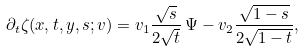Convert formula to latex. <formula><loc_0><loc_0><loc_500><loc_500>\partial _ { t } \zeta ( x , t , y , s ; v ) = v _ { 1 } \frac { \sqrt { s } } { 2 \sqrt { t } } \, \Psi - v _ { 2 } \frac { \sqrt { 1 - s } } { 2 \sqrt { 1 - t } } ,</formula> 